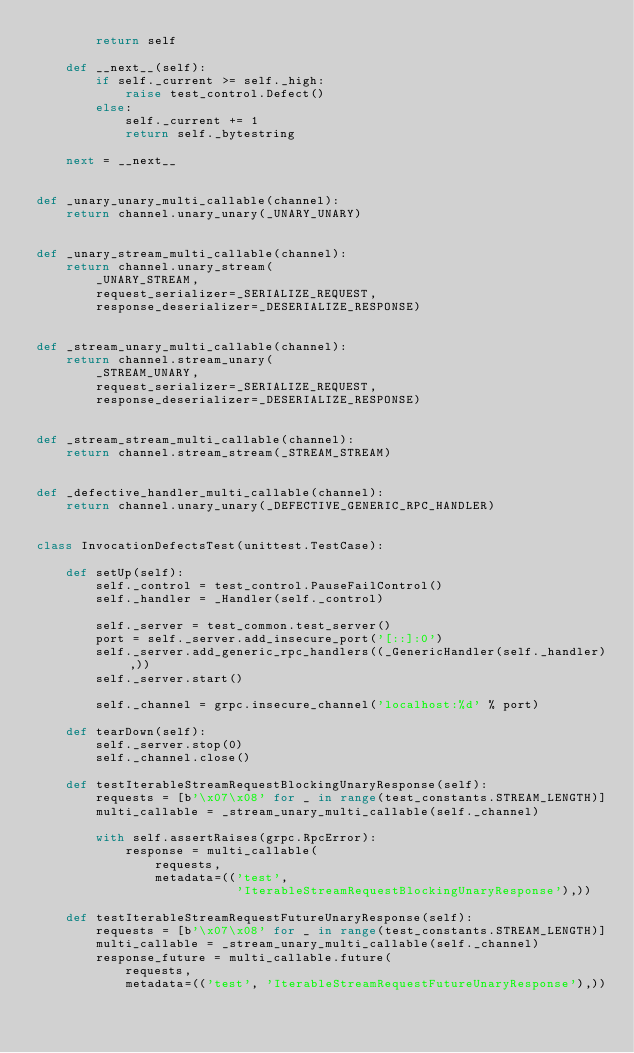<code> <loc_0><loc_0><loc_500><loc_500><_Python_>        return self

    def __next__(self):
        if self._current >= self._high:
            raise test_control.Defect()
        else:
            self._current += 1
            return self._bytestring

    next = __next__


def _unary_unary_multi_callable(channel):
    return channel.unary_unary(_UNARY_UNARY)


def _unary_stream_multi_callable(channel):
    return channel.unary_stream(
        _UNARY_STREAM,
        request_serializer=_SERIALIZE_REQUEST,
        response_deserializer=_DESERIALIZE_RESPONSE)


def _stream_unary_multi_callable(channel):
    return channel.stream_unary(
        _STREAM_UNARY,
        request_serializer=_SERIALIZE_REQUEST,
        response_deserializer=_DESERIALIZE_RESPONSE)


def _stream_stream_multi_callable(channel):
    return channel.stream_stream(_STREAM_STREAM)


def _defective_handler_multi_callable(channel):
    return channel.unary_unary(_DEFECTIVE_GENERIC_RPC_HANDLER)


class InvocationDefectsTest(unittest.TestCase):

    def setUp(self):
        self._control = test_control.PauseFailControl()
        self._handler = _Handler(self._control)

        self._server = test_common.test_server()
        port = self._server.add_insecure_port('[::]:0')
        self._server.add_generic_rpc_handlers((_GenericHandler(self._handler),))
        self._server.start()

        self._channel = grpc.insecure_channel('localhost:%d' % port)

    def tearDown(self):
        self._server.stop(0)
        self._channel.close()

    def testIterableStreamRequestBlockingUnaryResponse(self):
        requests = [b'\x07\x08' for _ in range(test_constants.STREAM_LENGTH)]
        multi_callable = _stream_unary_multi_callable(self._channel)

        with self.assertRaises(grpc.RpcError):
            response = multi_callable(
                requests,
                metadata=(('test',
                           'IterableStreamRequestBlockingUnaryResponse'),))

    def testIterableStreamRequestFutureUnaryResponse(self):
        requests = [b'\x07\x08' for _ in range(test_constants.STREAM_LENGTH)]
        multi_callable = _stream_unary_multi_callable(self._channel)
        response_future = multi_callable.future(
            requests,
            metadata=(('test', 'IterableStreamRequestFutureUnaryResponse'),))
</code> 